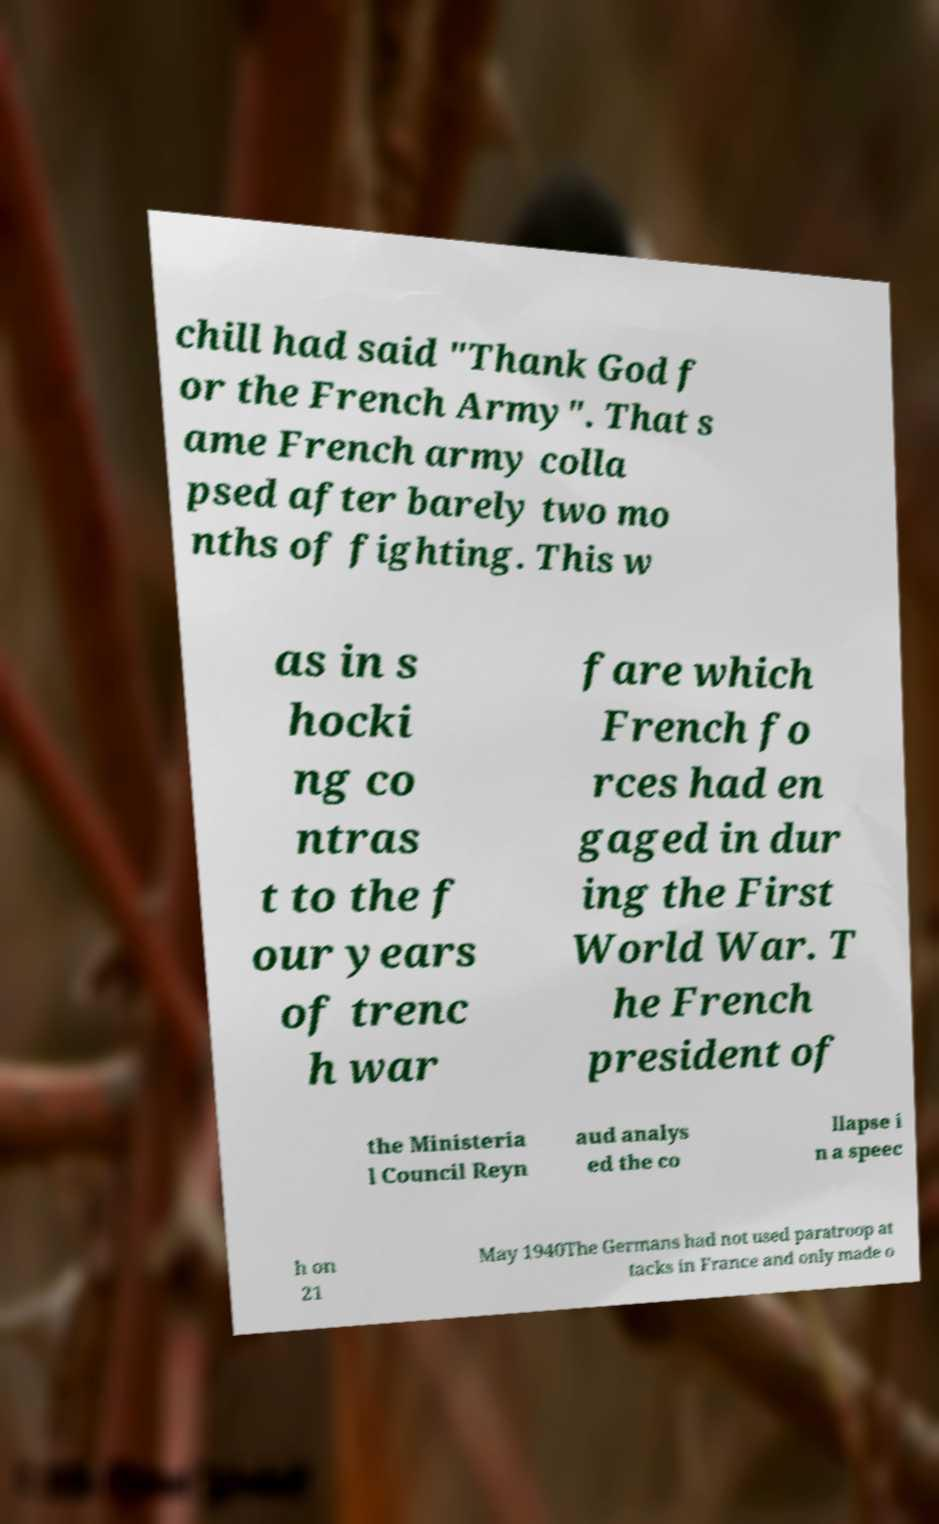Please read and relay the text visible in this image. What does it say? chill had said "Thank God f or the French Army". That s ame French army colla psed after barely two mo nths of fighting. This w as in s hocki ng co ntras t to the f our years of trenc h war fare which French fo rces had en gaged in dur ing the First World War. T he French president of the Ministeria l Council Reyn aud analys ed the co llapse i n a speec h on 21 May 1940The Germans had not used paratroop at tacks in France and only made o 